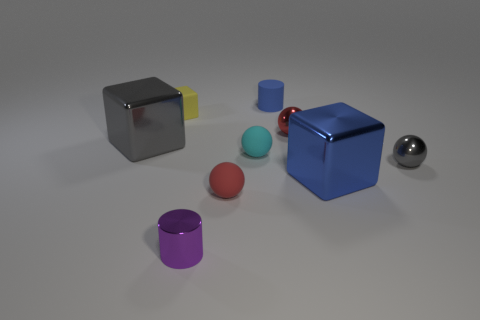There is a gray thing that is the same shape as the yellow object; what material is it? metal 